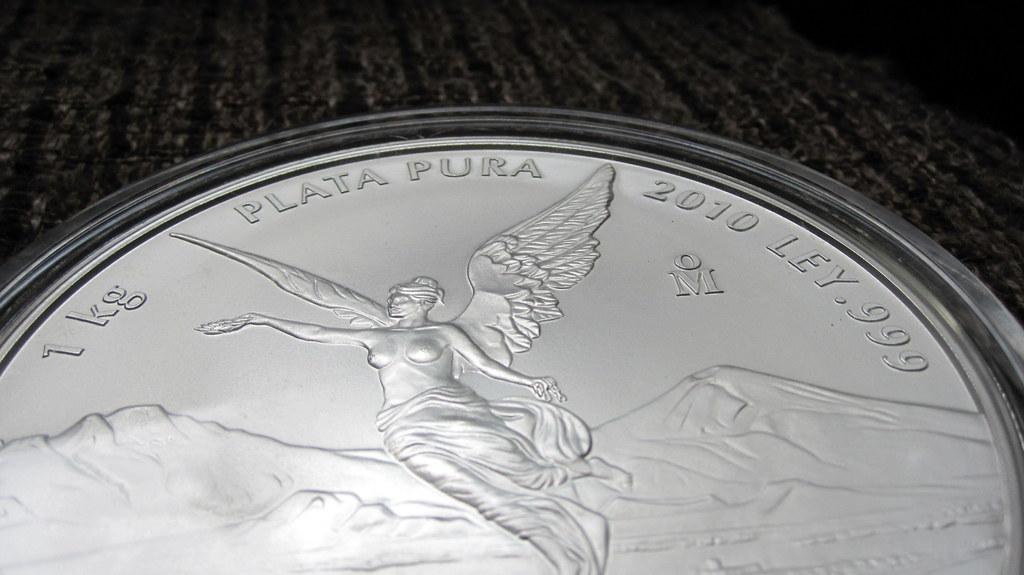Is that a coin?
Your response must be concise. Yes. What year was the coin made?
Offer a terse response. 2010. 